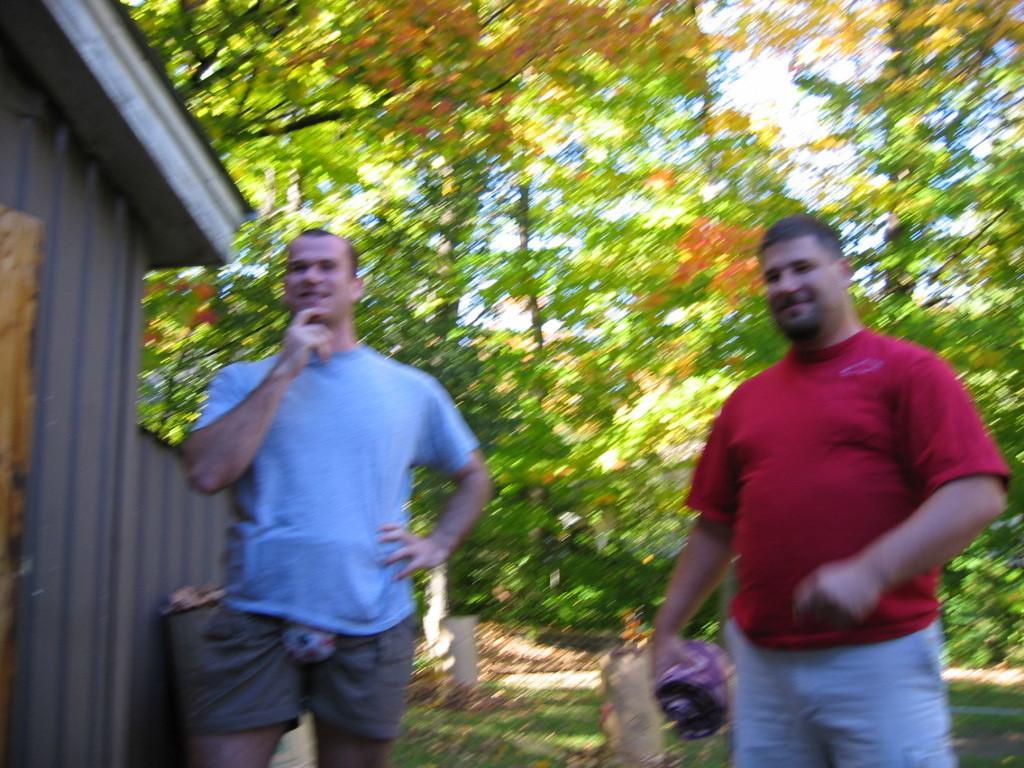Could you give a brief overview of what you see in this image? In this image in the center there are two persons who are standing and in the background there are some trees. On the left side there is one house, at the bottom there is grass. 